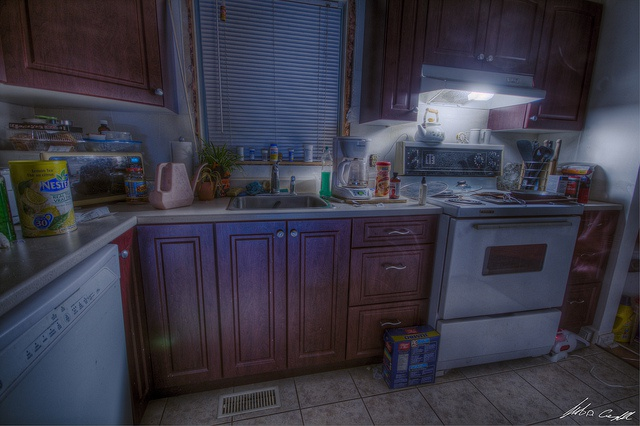Describe the objects in this image and their specific colors. I can see oven in black, gray, and darkblue tones, microwave in black, gray, navy, and darkblue tones, potted plant in black, maroon, and gray tones, sink in black, gray, and darkblue tones, and bottle in black, teal, and gray tones in this image. 